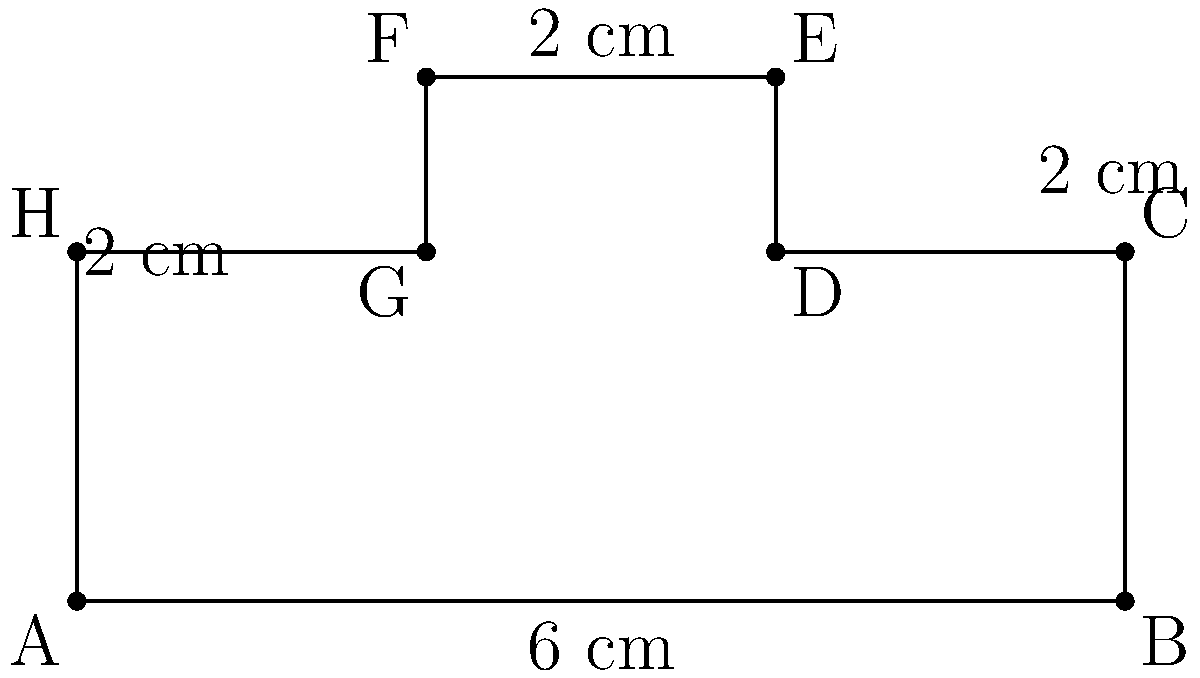As a graduate student researching the influence of names on personal identity, you're designing name tags for a conference. You've created an irregularly shaped name tag as shown in the figure. Calculate the perimeter of this name tag in centimeters. To calculate the perimeter of the irregularly shaped name tag, we need to sum up the lengths of all sides:

1. Side AB: 6 cm (given)
2. Side BC: 2 cm (given)
3. Side CD: 2 cm (given)
4. Side DE: 1 cm (difference between the two vertical segments on the right)
5. Side EF: 2 cm (given)
6. Side FG: 1 cm (difference between the two vertical segments on the left)
7. Side GH: 2 cm (given)
8. Side HA: 2 cm (given)

Now, let's sum up all these lengths:

$$\text{Perimeter} = 6 + 2 + 2 + 1 + 2 + 1 + 2 + 2 = 18 \text{ cm}$$

Therefore, the perimeter of the irregularly shaped name tag is 18 cm.
Answer: 18 cm 